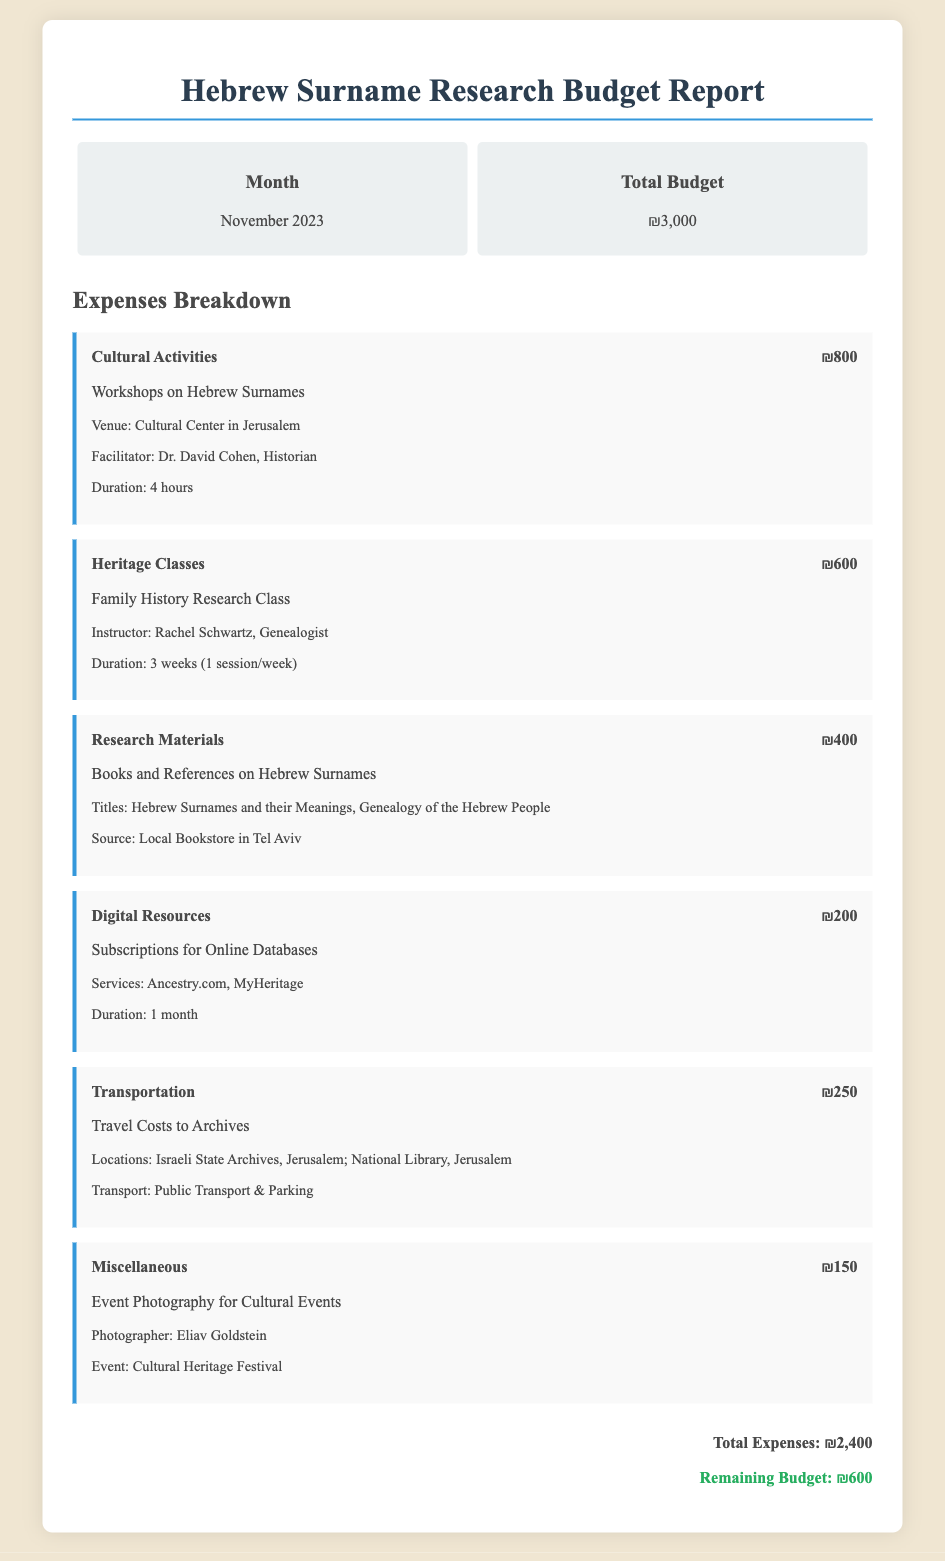What is the total budget? The total budget can be found in the document as listed under the budget overview section.
Answer: ₪3,000 Who is the facilitator for the workshops on Hebrew surnames? The facilitator's name is mentioned in the expenses breakdown for cultural activities.
Answer: Dr. David Cohen How much was spent on research materials? The expense for research materials is provided in the expenses breakdown.
Answer: ₪400 What is the duration of the family history research class? The duration of the class is detailed in the expenses section under heritage classes.
Answer: 3 weeks What type of digital resources were subscribed to? The document specifies the nature of the digital resources under the digital resources expense.
Answer: Online Databases What are the total expenses? The total expenses are calculated and stated at the bottom of the expenses section.
Answer: ₪2,400 What is the remaining budget after expenses? The remaining budget is shown in the total section of the document and reflects the amount left.
Answer: ₪600 Where were the workshops held? The location for the workshops is specified in the expenses section related to cultural activities.
Answer: Cultural Center in Jerusalem Who is responsible for event photography? The document identifies the photographer engaged for cultural events in the miscellaneous expense item.
Answer: Eliav Goldstein 